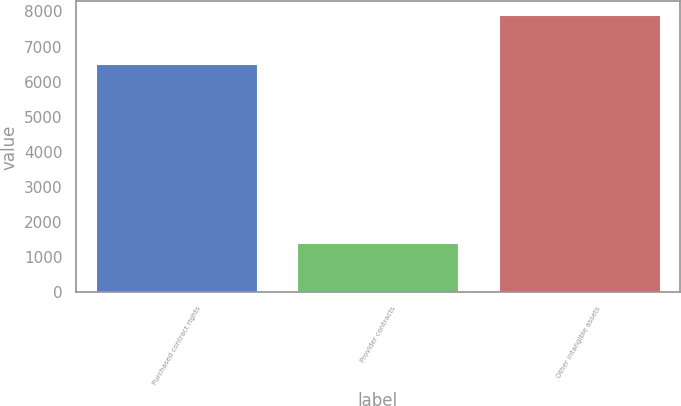Convert chart to OTSL. <chart><loc_0><loc_0><loc_500><loc_500><bar_chart><fcel>Purchased contract rights<fcel>Provider contracts<fcel>Other intangible assets<nl><fcel>6492<fcel>1400<fcel>7892<nl></chart> 